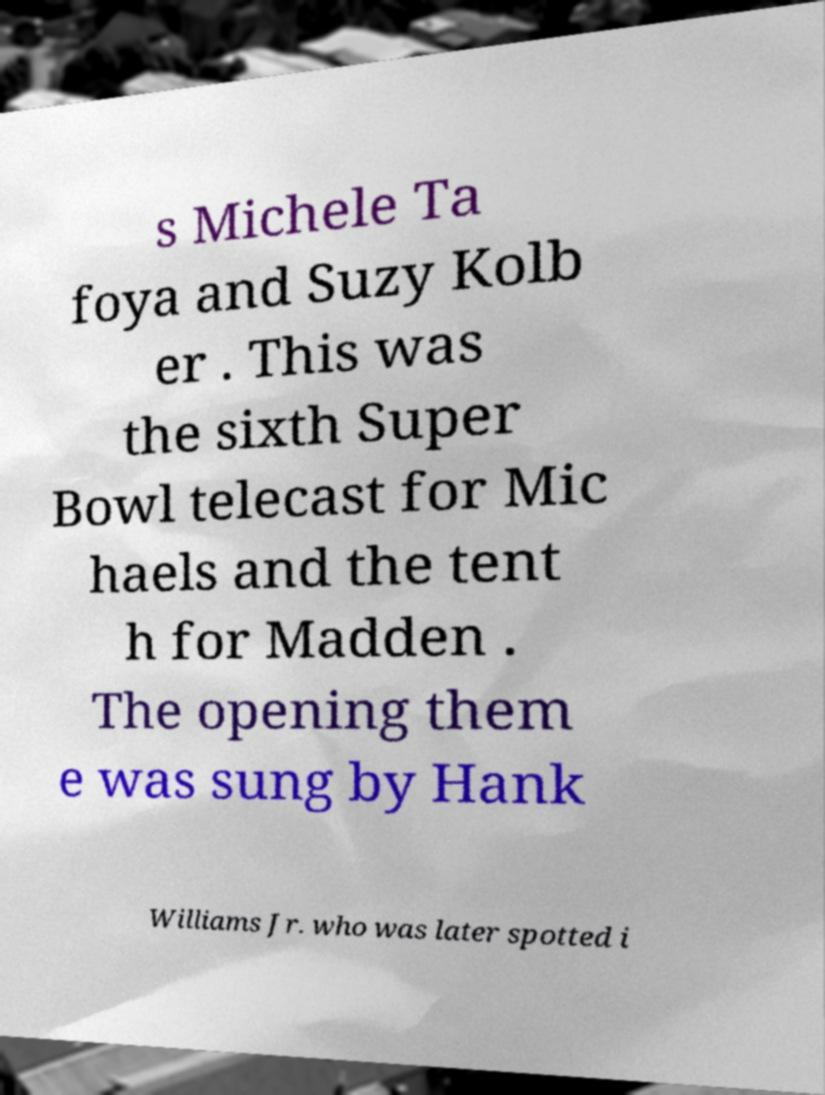Please identify and transcribe the text found in this image. s Michele Ta foya and Suzy Kolb er . This was the sixth Super Bowl telecast for Mic haels and the tent h for Madden . The opening them e was sung by Hank Williams Jr. who was later spotted i 